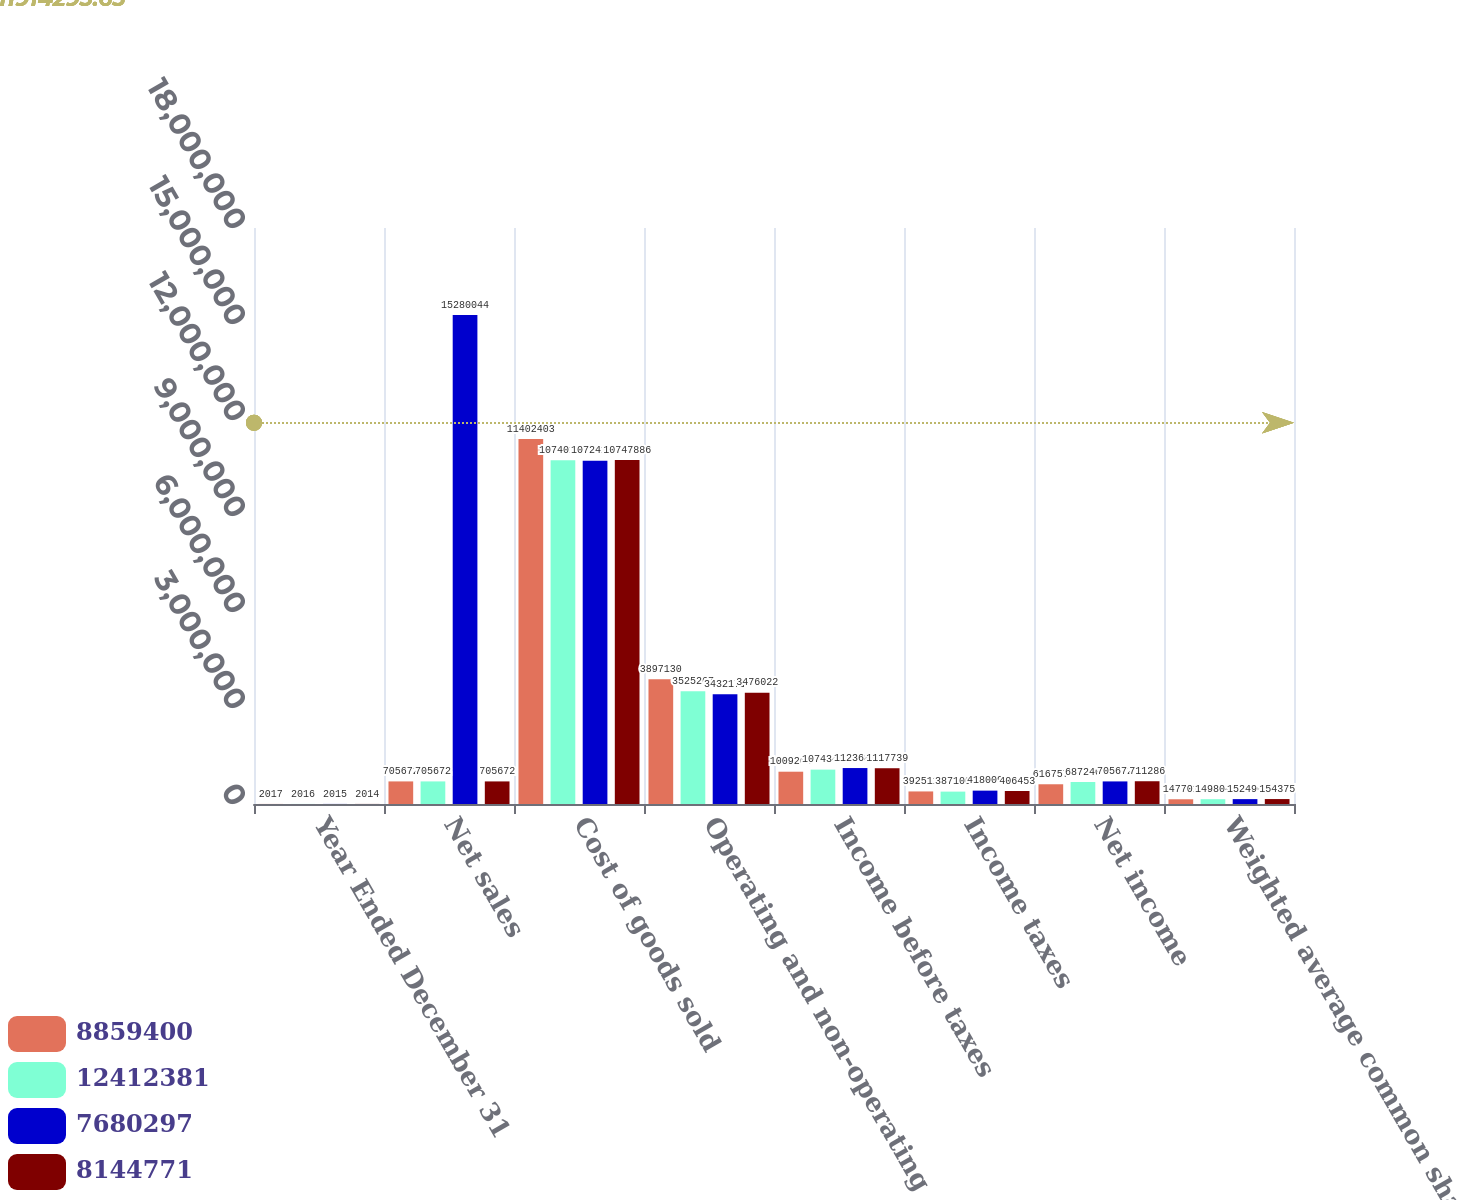Convert chart to OTSL. <chart><loc_0><loc_0><loc_500><loc_500><stacked_bar_chart><ecel><fcel>Year Ended December 31<fcel>Net sales<fcel>Cost of goods sold<fcel>Operating and non-operating<fcel>Income before taxes<fcel>Income taxes<fcel>Net income<fcel>Weighted average common shares<nl><fcel>8.8594e+06<fcel>2017<fcel>705672<fcel>1.14024e+07<fcel>3.89713e+06<fcel>1.00927e+06<fcel>392511<fcel>616757<fcel>147701<nl><fcel>1.24124e+07<fcel>2016<fcel>705672<fcel>1.07401e+07<fcel>3.52527e+06<fcel>1.07434e+06<fcel>387100<fcel>687240<fcel>149804<nl><fcel>7.6803e+06<fcel>2015<fcel>1.528e+07<fcel>1.07242e+07<fcel>3.43217e+06<fcel>1.12368e+06<fcel>418009<fcel>705672<fcel>152496<nl><fcel>8.14477e+06<fcel>2014<fcel>705672<fcel>1.07479e+07<fcel>3.47602e+06<fcel>1.11774e+06<fcel>406453<fcel>711286<fcel>154375<nl></chart> 